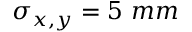<formula> <loc_0><loc_0><loc_500><loc_500>\sigma _ { x , y } = 5 m m</formula> 